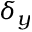<formula> <loc_0><loc_0><loc_500><loc_500>\delta _ { y }</formula> 